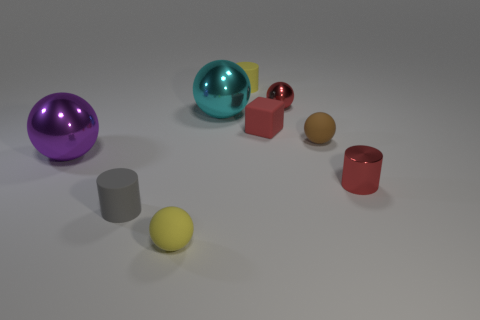Is there a cube that has the same color as the tiny metal sphere?
Provide a short and direct response. Yes. The small cylinder that is behind the shiny sphere behind the big cyan ball is made of what material?
Ensure brevity in your answer.  Rubber. There is a sphere that is left of the small yellow matte sphere; what is its material?
Provide a short and direct response. Metal. What number of small gray rubber things have the same shape as the large purple metal thing?
Provide a short and direct response. 0. Do the block and the tiny shiny ball have the same color?
Offer a very short reply. Yes. What is the material of the yellow object behind the tiny cylinder on the right side of the tiny cylinder behind the small brown rubber ball?
Provide a succinct answer. Rubber. There is a tiny red block; are there any red metal cylinders behind it?
Your answer should be compact. No. What shape is the gray rubber thing that is the same size as the red rubber object?
Offer a terse response. Cylinder. Is the big cyan sphere made of the same material as the red cylinder?
Your answer should be compact. Yes. What number of shiny objects are big yellow spheres or brown objects?
Offer a terse response. 0. 